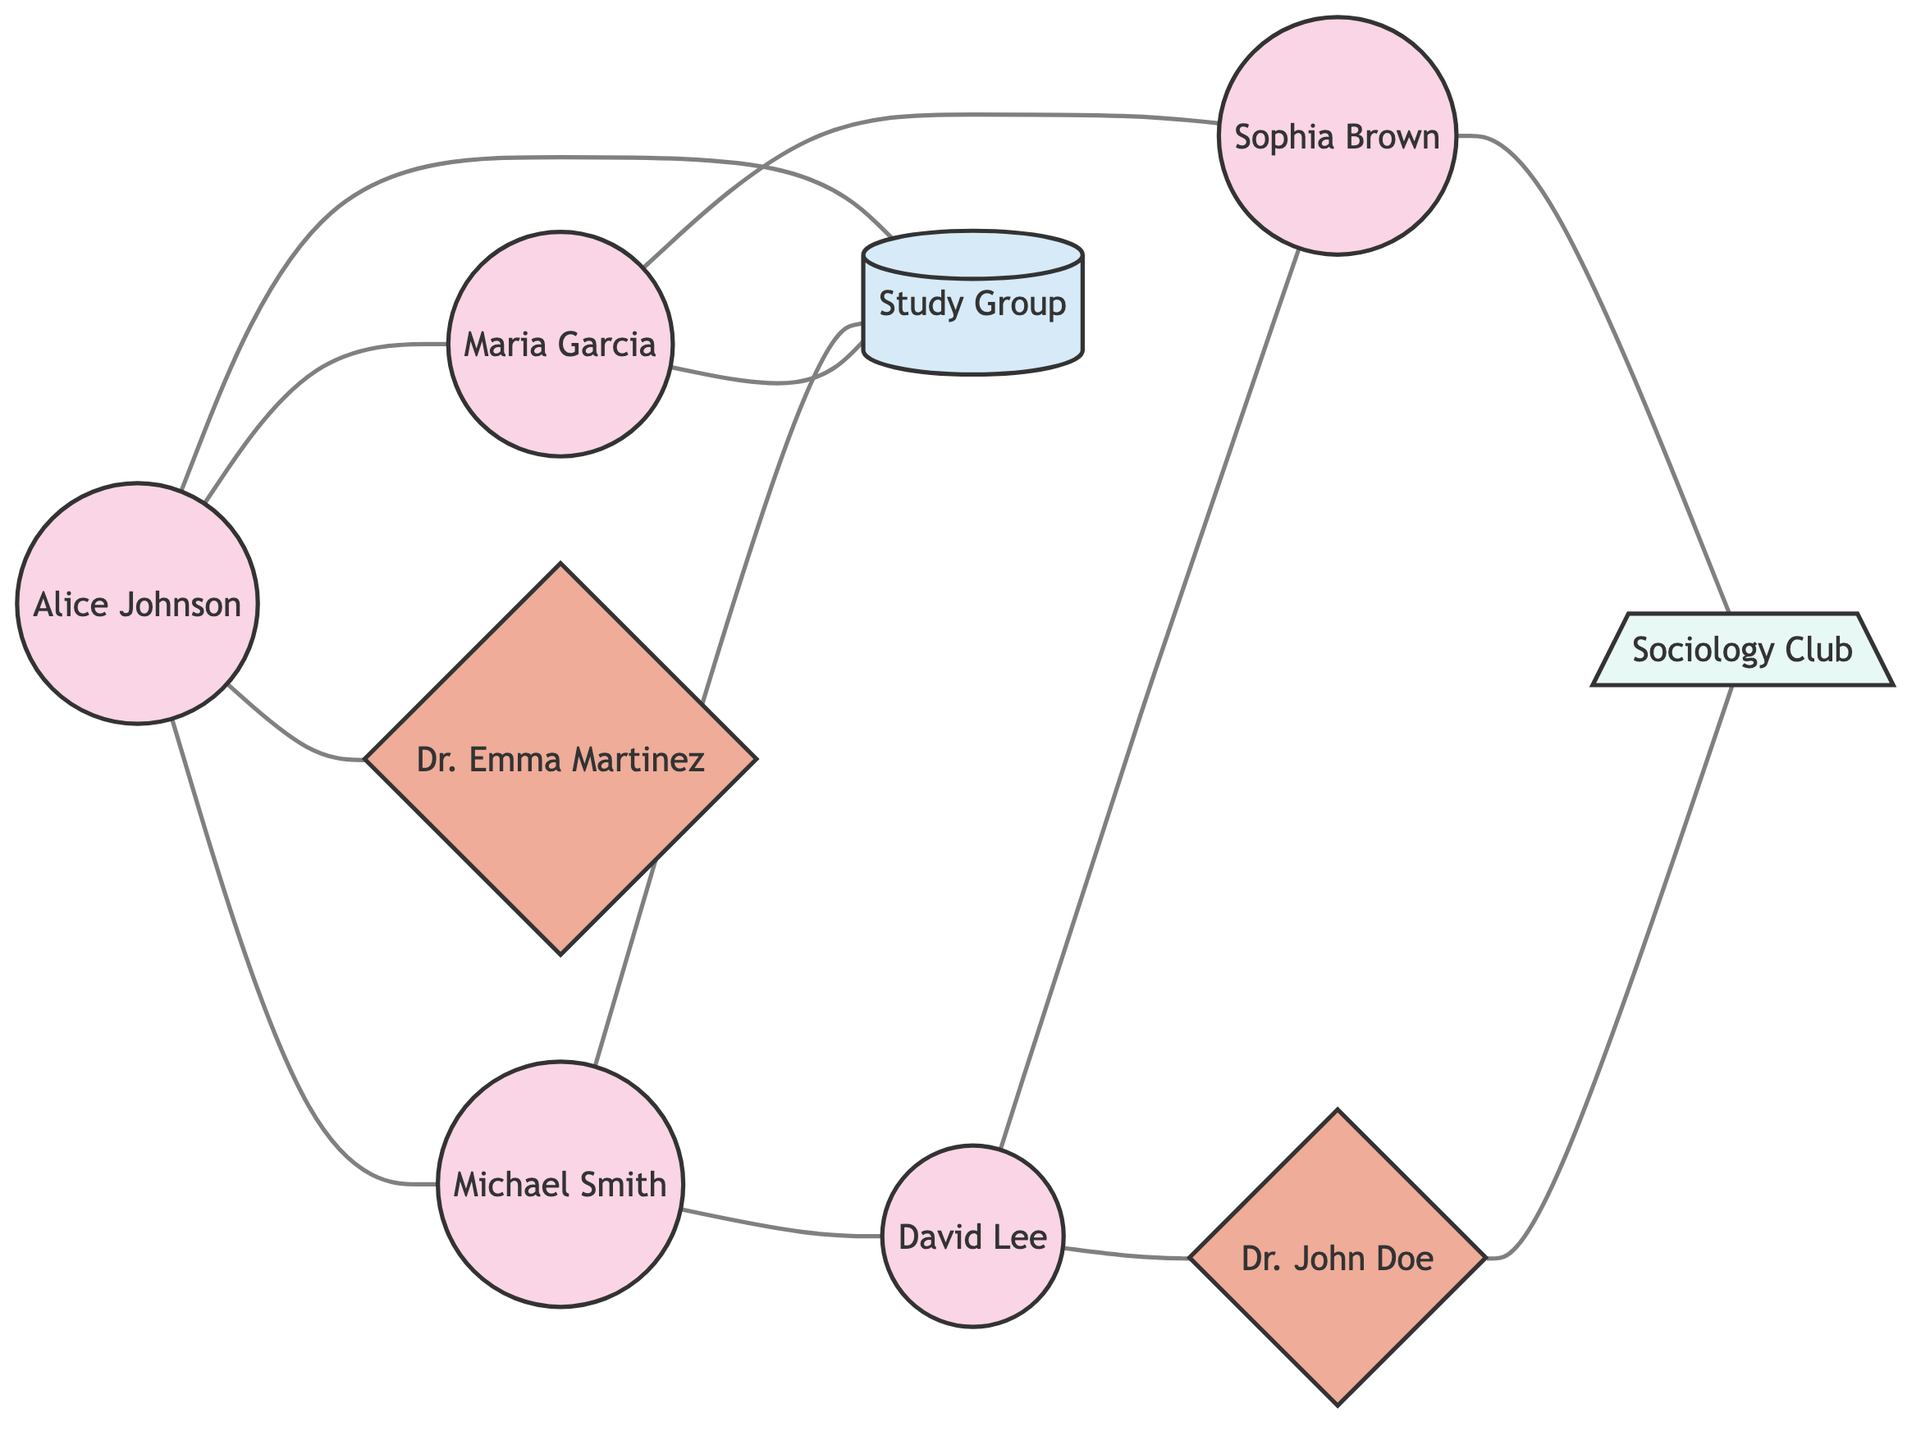What is the total number of nodes in the diagram? To find the total number of nodes, I count each unique entity listed in the nodes section. There are nine entities including students, mentors, a study group, and a club.
Answer: 9 Which student is directly connected to Michael Smith? I examine the edges connected to Michael Smith (Student_B) in the diagram. The edges indicate that Alice Johnson (Student_A) and David Lee (Student_D) are directly connected to Michael Smith.
Answer: Alice Johnson, David Lee How many edges are associated with Maria Garcia? To determine the number of edges for Maria Garcia (Student_C), I review the connections shown in the edges section. Maria is connected to Alice Johnson, Sophia Brown, and the study group, resulting in three edges.
Answer: 3 Which mentor is associated with both David Lee and the Sociology Club? I trace the connections from David Lee (Student_D) and the Sociology Club (Club_A). According to the edges, Dr. John Doe (Mentor_B) is connected to both David Lee and the Sociology Club.
Answer: Dr. John Doe What are the names of all students who are connected to the Study Group? I identify which students are connected to the Study Group from the edges. Alice Johnson, Michael Smith, and Maria Garcia are all directly connected to the Study Group.
Answer: Alice Johnson, Michael Smith, Maria Garcia How many direct connections does Alice Johnson have? To find Alice Johnson's direct connections, I review all the edges originating from her. She has connections to Michael Smith, Maria Garcia, David Lee, and the Study Group, totaling four direct connections.
Answer: 4 Which node has the most connections, and how many connections does it have? I assess the number of edges for each node. Alice Johnson has four connections, which is the highest among all nodes, followed by David Lee and others with fewer.
Answer: Alice Johnson, 4 What is the relationship between Sophia Brown and the Sociology Club? I look for direct connections involving Sophia Brown. The edge indicates that she has a connection with the Sociology Club, showing a direct participation or involvement.
Answer: Connected Is there a node with no connections? If so, which one? I review each node to see if any have no edges attached. Looking through the data provided, all nodes have at least one edge indicating connections, hence no disconnected nodes.
Answer: No 